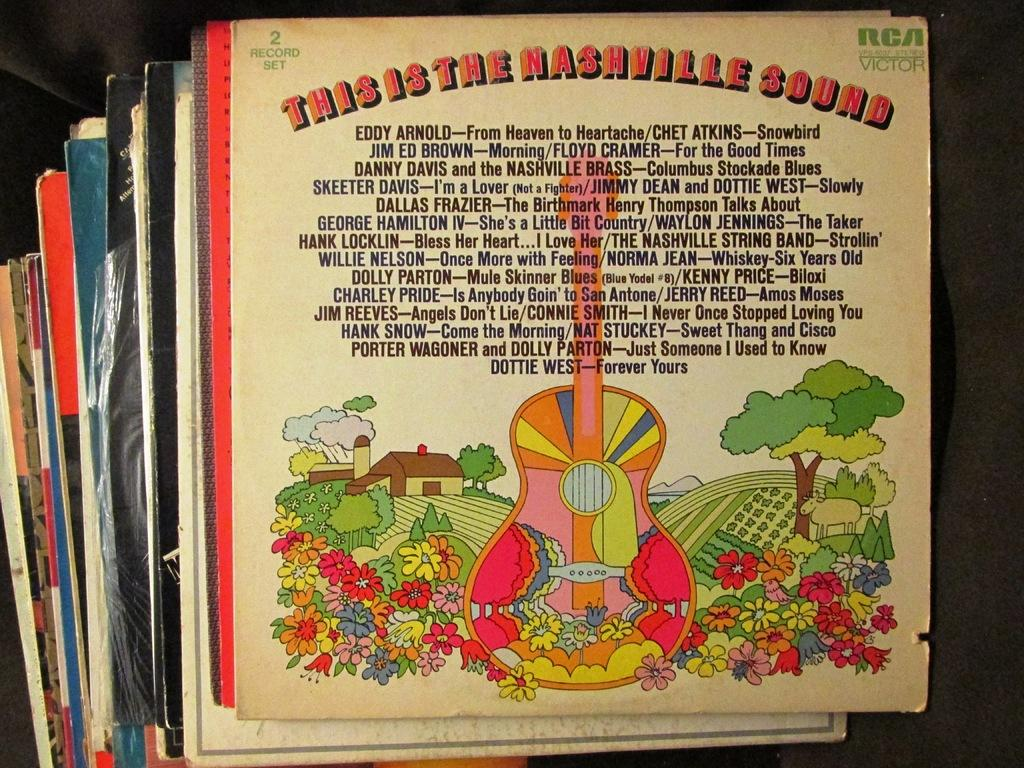Provide a one-sentence caption for the provided image. A stack of records in their sleeves, with the topmost record being This Is The Nashville Sound. 